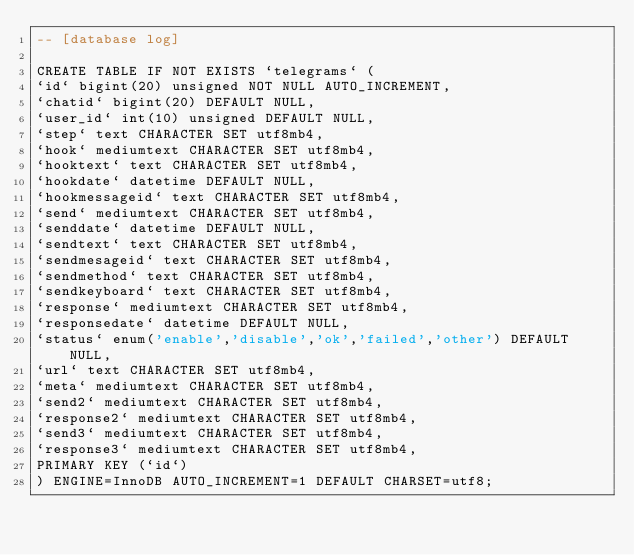Convert code to text. <code><loc_0><loc_0><loc_500><loc_500><_SQL_>-- [database log]

CREATE TABLE IF NOT EXISTS `telegrams` (
`id` bigint(20) unsigned NOT NULL AUTO_INCREMENT,
`chatid` bigint(20) DEFAULT NULL,
`user_id` int(10) unsigned DEFAULT NULL,
`step` text CHARACTER SET utf8mb4,
`hook` mediumtext CHARACTER SET utf8mb4,
`hooktext` text CHARACTER SET utf8mb4,
`hookdate` datetime DEFAULT NULL,
`hookmessageid` text CHARACTER SET utf8mb4,
`send` mediumtext CHARACTER SET utf8mb4,
`senddate` datetime DEFAULT NULL,
`sendtext` text CHARACTER SET utf8mb4,
`sendmesageid` text CHARACTER SET utf8mb4,
`sendmethod` text CHARACTER SET utf8mb4,
`sendkeyboard` text CHARACTER SET utf8mb4,
`response` mediumtext CHARACTER SET utf8mb4,
`responsedate` datetime DEFAULT NULL,
`status` enum('enable','disable','ok','failed','other') DEFAULT NULL,
`url` text CHARACTER SET utf8mb4,
`meta` mediumtext CHARACTER SET utf8mb4,
`send2` mediumtext CHARACTER SET utf8mb4,
`response2` mediumtext CHARACTER SET utf8mb4,
`send3` mediumtext CHARACTER SET utf8mb4,
`response3` mediumtext CHARACTER SET utf8mb4,
PRIMARY KEY (`id`)
) ENGINE=InnoDB AUTO_INCREMENT=1 DEFAULT CHARSET=utf8;

</code> 